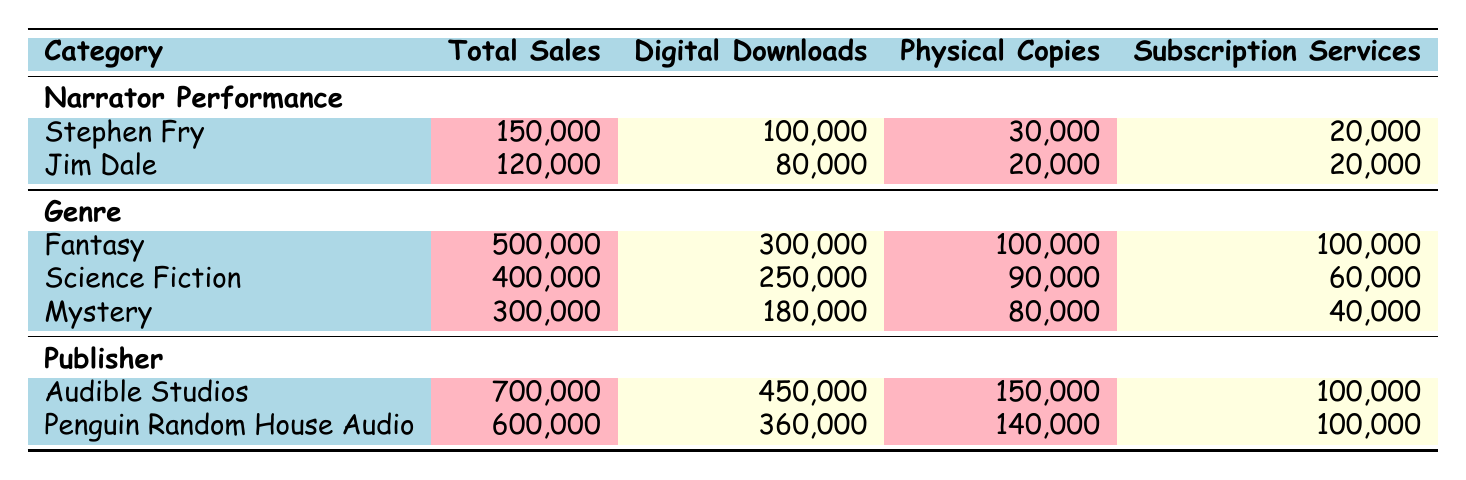What was the total sales for Stephen Fry's audiobooks? According to the table, under the "Narrator Performance" category, Stephen Fry has total sales of 150,000.
Answer: 150,000 What genre had the highest total sales? The table shows that the "Fantasy" genre has the highest total sales at 500,000, compared to Science Fiction at 400,000 and Mystery at 300,000.
Answer: Fantasy Did Jim Dale sell more physical copies or digital downloads? From the table, Jim Dale's digital downloads are 80,000 while his physical copies are 20,000, meaning he sold more digital downloads.
Answer: Yes What is the total income from all audiobook sales under the "Publisher" category? To find the total income from all publishers, we add the total sales of Audible Studios (700,000) and Penguin Random House Audio (600,000), which equals 1,300,000.
Answer: 1,300,000 Which narrator had the highest sales in subscription services, Stephen Fry or Jim Dale? Looking at the subscription services row for both narrators, they both have 20,000, so neither had higher sales than the other; they are equal.
Answer: No What is the average number of digital downloads across all genres? To calculate the average digital downloads, we first sum the digital downloads: 300,000 (Fantasy) + 250,000 (Science Fiction) + 180,000 (Mystery) = 730,000. There are 3 genres, so the average is 730,000 / 3 = 243,333.33. Rounded, this is 243,333.
Answer: 243,333 Is Amazon’s Audible Studios the top publisher based on total sales? Looking at the total sales, Audible Studios has 700,000 while Penguin Random House Audio has 600,000, so yes, Audible Studios is the top publisher.
Answer: Yes What is the difference in total sales between the Fantasy and Science Fiction genres? The total sales for Fantasy is 500,000 and for Science Fiction it is 400,000. The difference is 500,000 - 400,000 = 100,000.
Answer: 100,000 Which audiobook category has more total sales, narrator performance or genre? The total sales for narrators (Stephen Fry + Jim Dale) is 150,000 + 120,000 = 270,000. For genres, it sums to 500,000 + 400,000 + 300,000 = 1,200,000. Thus, genre has more sales.
Answer: Genre 